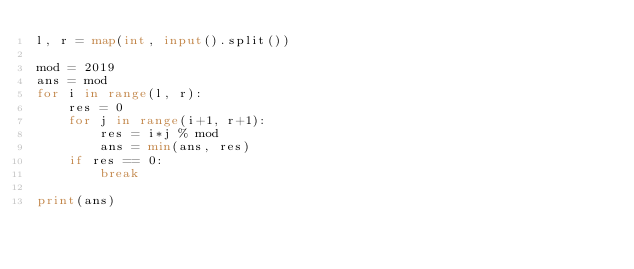<code> <loc_0><loc_0><loc_500><loc_500><_Python_>l, r = map(int, input().split())

mod = 2019
ans = mod
for i in range(l, r):
    res = 0
    for j in range(i+1, r+1):
        res = i*j % mod
        ans = min(ans, res)
    if res == 0:
        break

print(ans)</code> 